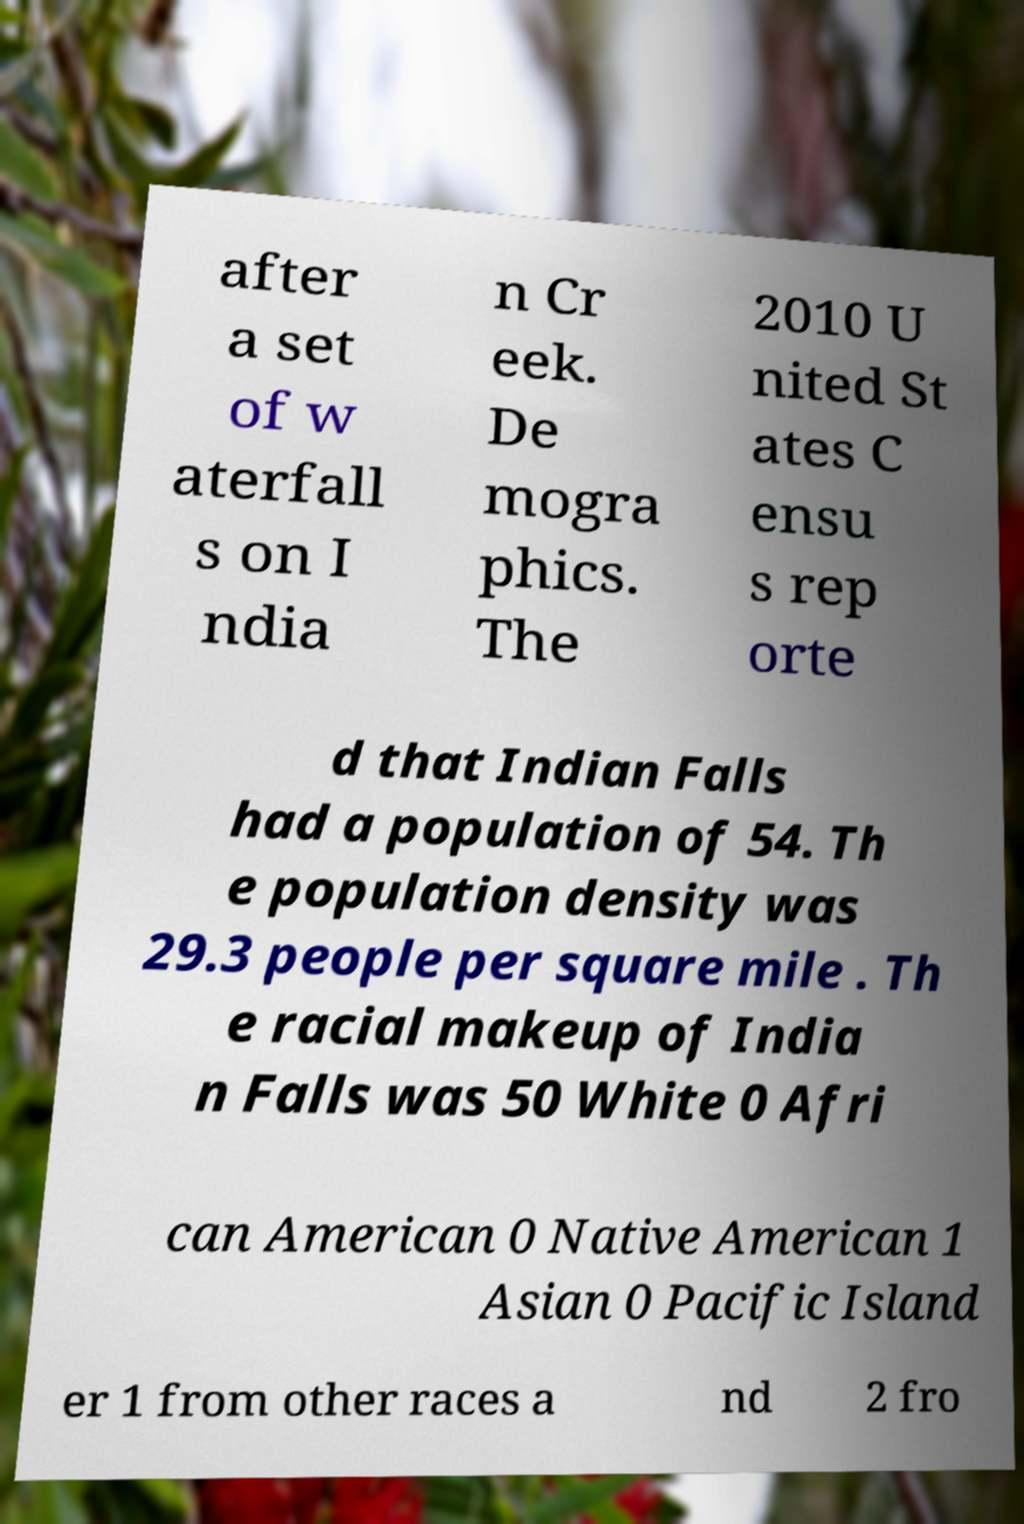I need the written content from this picture converted into text. Can you do that? after a set of w aterfall s on I ndia n Cr eek. De mogra phics. The 2010 U nited St ates C ensu s rep orte d that Indian Falls had a population of 54. Th e population density was 29.3 people per square mile . Th e racial makeup of India n Falls was 50 White 0 Afri can American 0 Native American 1 Asian 0 Pacific Island er 1 from other races a nd 2 fro 